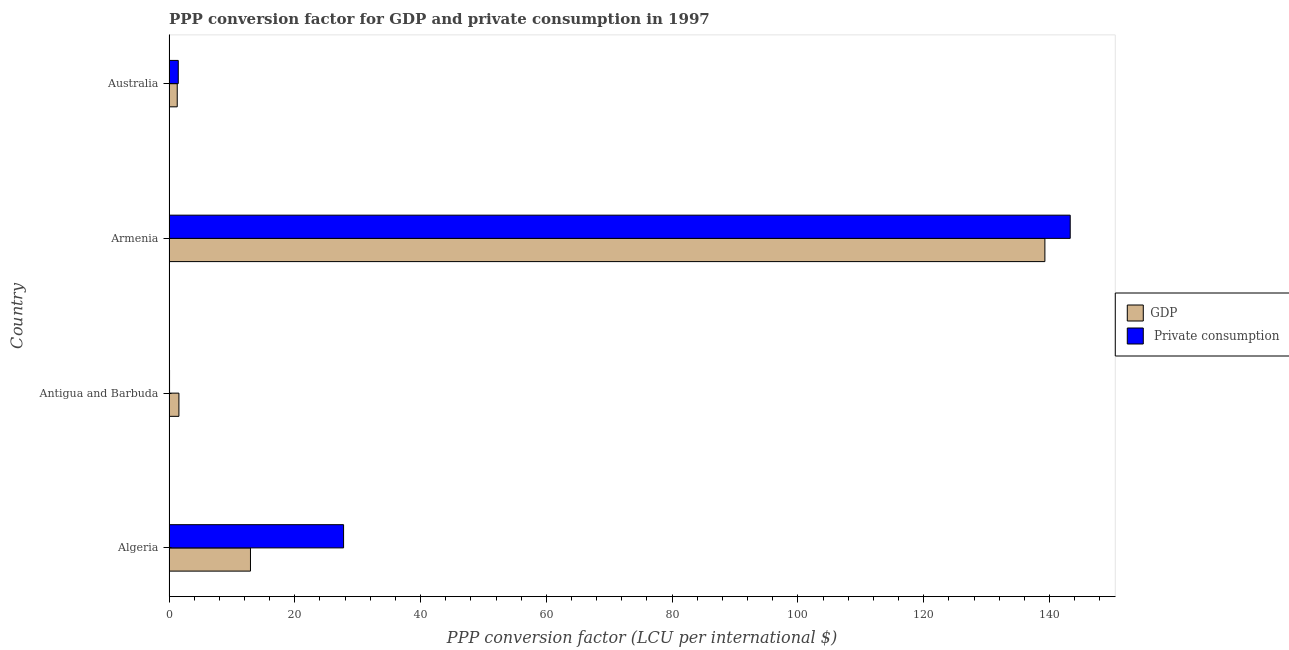How many different coloured bars are there?
Your response must be concise. 2. How many groups of bars are there?
Ensure brevity in your answer.  4. How many bars are there on the 1st tick from the top?
Offer a very short reply. 2. How many bars are there on the 3rd tick from the bottom?
Make the answer very short. 2. What is the label of the 4th group of bars from the top?
Ensure brevity in your answer.  Algeria. What is the ppp conversion factor for private consumption in Antigua and Barbuda?
Your response must be concise. 0.09. Across all countries, what is the maximum ppp conversion factor for private consumption?
Provide a short and direct response. 143.29. Across all countries, what is the minimum ppp conversion factor for private consumption?
Your answer should be compact. 0.09. In which country was the ppp conversion factor for gdp maximum?
Offer a very short reply. Armenia. In which country was the ppp conversion factor for gdp minimum?
Keep it short and to the point. Australia. What is the total ppp conversion factor for gdp in the graph?
Provide a succinct answer. 155.11. What is the difference between the ppp conversion factor for gdp in Algeria and that in Antigua and Barbuda?
Make the answer very short. 11.38. What is the difference between the ppp conversion factor for gdp in Antigua and Barbuda and the ppp conversion factor for private consumption in Armenia?
Give a very brief answer. -141.72. What is the average ppp conversion factor for private consumption per country?
Your response must be concise. 43.15. What is the difference between the ppp conversion factor for private consumption and ppp conversion factor for gdp in Australia?
Make the answer very short. 0.16. In how many countries, is the ppp conversion factor for gdp greater than 132 LCU?
Offer a very short reply. 1. What is the ratio of the ppp conversion factor for private consumption in Antigua and Barbuda to that in Australia?
Your response must be concise. 0.06. Is the ppp conversion factor for private consumption in Antigua and Barbuda less than that in Armenia?
Offer a very short reply. Yes. Is the difference between the ppp conversion factor for gdp in Antigua and Barbuda and Armenia greater than the difference between the ppp conversion factor for private consumption in Antigua and Barbuda and Armenia?
Ensure brevity in your answer.  Yes. What is the difference between the highest and the second highest ppp conversion factor for private consumption?
Your answer should be very brief. 115.53. What is the difference between the highest and the lowest ppp conversion factor for gdp?
Provide a short and direct response. 137.96. What does the 2nd bar from the top in Armenia represents?
Provide a short and direct response. GDP. What does the 1st bar from the bottom in Armenia represents?
Provide a short and direct response. GDP. How many bars are there?
Your answer should be very brief. 8. Are all the bars in the graph horizontal?
Offer a very short reply. Yes. What is the difference between two consecutive major ticks on the X-axis?
Provide a succinct answer. 20. Are the values on the major ticks of X-axis written in scientific E-notation?
Your answer should be very brief. No. Does the graph contain any zero values?
Ensure brevity in your answer.  No. How many legend labels are there?
Offer a terse response. 2. How are the legend labels stacked?
Keep it short and to the point. Vertical. What is the title of the graph?
Your answer should be very brief. PPP conversion factor for GDP and private consumption in 1997. Does "Female population" appear as one of the legend labels in the graph?
Offer a terse response. No. What is the label or title of the X-axis?
Provide a succinct answer. PPP conversion factor (LCU per international $). What is the label or title of the Y-axis?
Offer a very short reply. Country. What is the PPP conversion factor (LCU per international $) of GDP in Algeria?
Provide a short and direct response. 12.95. What is the PPP conversion factor (LCU per international $) in  Private consumption in Algeria?
Your answer should be very brief. 27.76. What is the PPP conversion factor (LCU per international $) of GDP in Antigua and Barbuda?
Your response must be concise. 1.58. What is the PPP conversion factor (LCU per international $) in  Private consumption in Antigua and Barbuda?
Offer a terse response. 0.09. What is the PPP conversion factor (LCU per international $) of GDP in Armenia?
Your answer should be very brief. 139.27. What is the PPP conversion factor (LCU per international $) of  Private consumption in Armenia?
Offer a terse response. 143.29. What is the PPP conversion factor (LCU per international $) in GDP in Australia?
Keep it short and to the point. 1.31. What is the PPP conversion factor (LCU per international $) of  Private consumption in Australia?
Your answer should be very brief. 1.47. Across all countries, what is the maximum PPP conversion factor (LCU per international $) of GDP?
Your answer should be very brief. 139.27. Across all countries, what is the maximum PPP conversion factor (LCU per international $) in  Private consumption?
Give a very brief answer. 143.29. Across all countries, what is the minimum PPP conversion factor (LCU per international $) of GDP?
Your answer should be compact. 1.31. Across all countries, what is the minimum PPP conversion factor (LCU per international $) of  Private consumption?
Your answer should be very brief. 0.09. What is the total PPP conversion factor (LCU per international $) in GDP in the graph?
Offer a terse response. 155.11. What is the total PPP conversion factor (LCU per international $) in  Private consumption in the graph?
Provide a succinct answer. 172.61. What is the difference between the PPP conversion factor (LCU per international $) in GDP in Algeria and that in Antigua and Barbuda?
Offer a terse response. 11.38. What is the difference between the PPP conversion factor (LCU per international $) in  Private consumption in Algeria and that in Antigua and Barbuda?
Provide a short and direct response. 27.67. What is the difference between the PPP conversion factor (LCU per international $) in GDP in Algeria and that in Armenia?
Ensure brevity in your answer.  -126.31. What is the difference between the PPP conversion factor (LCU per international $) in  Private consumption in Algeria and that in Armenia?
Keep it short and to the point. -115.54. What is the difference between the PPP conversion factor (LCU per international $) in GDP in Algeria and that in Australia?
Provide a short and direct response. 11.64. What is the difference between the PPP conversion factor (LCU per international $) in  Private consumption in Algeria and that in Australia?
Keep it short and to the point. 26.28. What is the difference between the PPP conversion factor (LCU per international $) of GDP in Antigua and Barbuda and that in Armenia?
Offer a terse response. -137.69. What is the difference between the PPP conversion factor (LCU per international $) of  Private consumption in Antigua and Barbuda and that in Armenia?
Your response must be concise. -143.21. What is the difference between the PPP conversion factor (LCU per international $) of GDP in Antigua and Barbuda and that in Australia?
Your answer should be compact. 0.27. What is the difference between the PPP conversion factor (LCU per international $) in  Private consumption in Antigua and Barbuda and that in Australia?
Your answer should be very brief. -1.39. What is the difference between the PPP conversion factor (LCU per international $) of GDP in Armenia and that in Australia?
Your answer should be compact. 137.96. What is the difference between the PPP conversion factor (LCU per international $) in  Private consumption in Armenia and that in Australia?
Your response must be concise. 141.82. What is the difference between the PPP conversion factor (LCU per international $) in GDP in Algeria and the PPP conversion factor (LCU per international $) in  Private consumption in Antigua and Barbuda?
Provide a short and direct response. 12.87. What is the difference between the PPP conversion factor (LCU per international $) of GDP in Algeria and the PPP conversion factor (LCU per international $) of  Private consumption in Armenia?
Offer a very short reply. -130.34. What is the difference between the PPP conversion factor (LCU per international $) of GDP in Algeria and the PPP conversion factor (LCU per international $) of  Private consumption in Australia?
Give a very brief answer. 11.48. What is the difference between the PPP conversion factor (LCU per international $) of GDP in Antigua and Barbuda and the PPP conversion factor (LCU per international $) of  Private consumption in Armenia?
Your answer should be very brief. -141.72. What is the difference between the PPP conversion factor (LCU per international $) in GDP in Antigua and Barbuda and the PPP conversion factor (LCU per international $) in  Private consumption in Australia?
Give a very brief answer. 0.1. What is the difference between the PPP conversion factor (LCU per international $) in GDP in Armenia and the PPP conversion factor (LCU per international $) in  Private consumption in Australia?
Provide a short and direct response. 137.79. What is the average PPP conversion factor (LCU per international $) of GDP per country?
Make the answer very short. 38.78. What is the average PPP conversion factor (LCU per international $) of  Private consumption per country?
Offer a very short reply. 43.15. What is the difference between the PPP conversion factor (LCU per international $) of GDP and PPP conversion factor (LCU per international $) of  Private consumption in Algeria?
Offer a very short reply. -14.8. What is the difference between the PPP conversion factor (LCU per international $) of GDP and PPP conversion factor (LCU per international $) of  Private consumption in Antigua and Barbuda?
Your answer should be very brief. 1.49. What is the difference between the PPP conversion factor (LCU per international $) of GDP and PPP conversion factor (LCU per international $) of  Private consumption in Armenia?
Your response must be concise. -4.03. What is the difference between the PPP conversion factor (LCU per international $) of GDP and PPP conversion factor (LCU per international $) of  Private consumption in Australia?
Offer a very short reply. -0.16. What is the ratio of the PPP conversion factor (LCU per international $) in GDP in Algeria to that in Antigua and Barbuda?
Ensure brevity in your answer.  8.21. What is the ratio of the PPP conversion factor (LCU per international $) of  Private consumption in Algeria to that in Antigua and Barbuda?
Provide a succinct answer. 321. What is the ratio of the PPP conversion factor (LCU per international $) of GDP in Algeria to that in Armenia?
Ensure brevity in your answer.  0.09. What is the ratio of the PPP conversion factor (LCU per international $) of  Private consumption in Algeria to that in Armenia?
Ensure brevity in your answer.  0.19. What is the ratio of the PPP conversion factor (LCU per international $) in GDP in Algeria to that in Australia?
Keep it short and to the point. 9.88. What is the ratio of the PPP conversion factor (LCU per international $) in  Private consumption in Algeria to that in Australia?
Provide a short and direct response. 18.83. What is the ratio of the PPP conversion factor (LCU per international $) of GDP in Antigua and Barbuda to that in Armenia?
Provide a succinct answer. 0.01. What is the ratio of the PPP conversion factor (LCU per international $) of  Private consumption in Antigua and Barbuda to that in Armenia?
Make the answer very short. 0. What is the ratio of the PPP conversion factor (LCU per international $) of GDP in Antigua and Barbuda to that in Australia?
Provide a short and direct response. 1.2. What is the ratio of the PPP conversion factor (LCU per international $) in  Private consumption in Antigua and Barbuda to that in Australia?
Provide a short and direct response. 0.06. What is the ratio of the PPP conversion factor (LCU per international $) in GDP in Armenia to that in Australia?
Make the answer very short. 106.27. What is the ratio of the PPP conversion factor (LCU per international $) of  Private consumption in Armenia to that in Australia?
Give a very brief answer. 97.19. What is the difference between the highest and the second highest PPP conversion factor (LCU per international $) of GDP?
Your answer should be compact. 126.31. What is the difference between the highest and the second highest PPP conversion factor (LCU per international $) of  Private consumption?
Ensure brevity in your answer.  115.54. What is the difference between the highest and the lowest PPP conversion factor (LCU per international $) of GDP?
Keep it short and to the point. 137.96. What is the difference between the highest and the lowest PPP conversion factor (LCU per international $) of  Private consumption?
Provide a succinct answer. 143.21. 